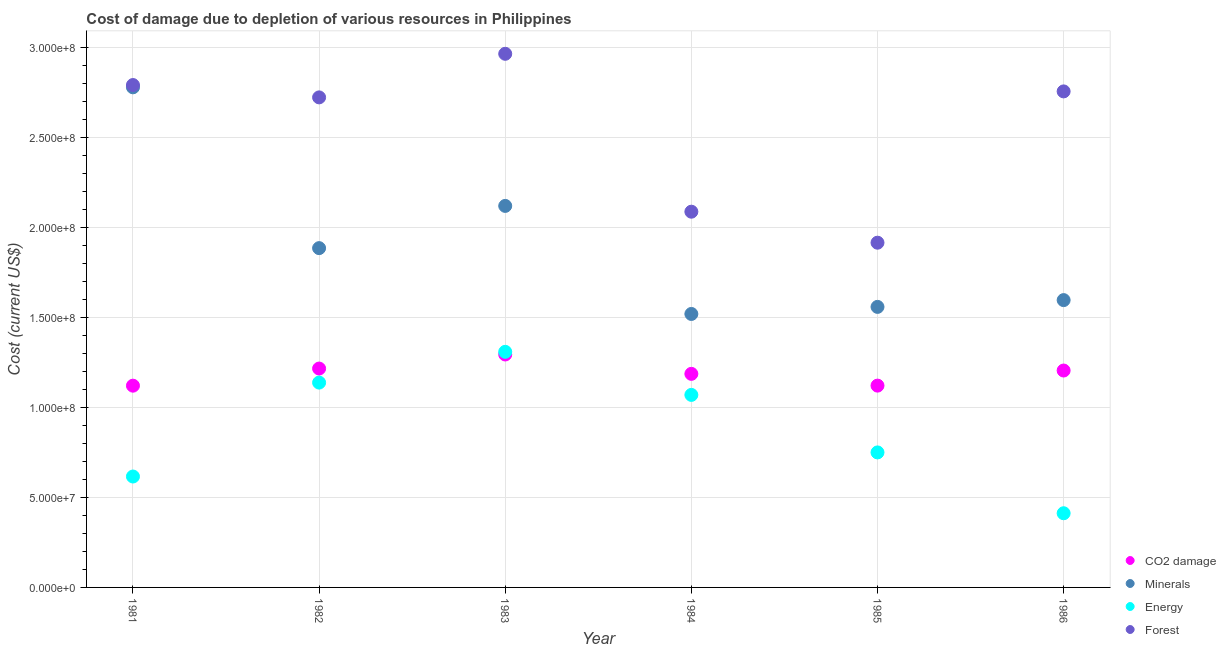How many different coloured dotlines are there?
Provide a succinct answer. 4. Is the number of dotlines equal to the number of legend labels?
Your answer should be compact. Yes. What is the cost of damage due to depletion of forests in 1981?
Provide a succinct answer. 2.79e+08. Across all years, what is the maximum cost of damage due to depletion of coal?
Ensure brevity in your answer.  1.29e+08. Across all years, what is the minimum cost of damage due to depletion of coal?
Provide a short and direct response. 1.12e+08. In which year was the cost of damage due to depletion of forests maximum?
Offer a very short reply. 1983. In which year was the cost of damage due to depletion of forests minimum?
Provide a succinct answer. 1985. What is the total cost of damage due to depletion of coal in the graph?
Provide a succinct answer. 7.14e+08. What is the difference between the cost of damage due to depletion of coal in 1983 and that in 1986?
Your response must be concise. 8.91e+06. What is the difference between the cost of damage due to depletion of minerals in 1985 and the cost of damage due to depletion of energy in 1986?
Offer a very short reply. 1.15e+08. What is the average cost of damage due to depletion of energy per year?
Ensure brevity in your answer.  8.82e+07. In the year 1986, what is the difference between the cost of damage due to depletion of energy and cost of damage due to depletion of minerals?
Keep it short and to the point. -1.18e+08. What is the ratio of the cost of damage due to depletion of coal in 1983 to that in 1986?
Your response must be concise. 1.07. Is the cost of damage due to depletion of coal in 1983 less than that in 1985?
Keep it short and to the point. No. Is the difference between the cost of damage due to depletion of forests in 1981 and 1983 greater than the difference between the cost of damage due to depletion of minerals in 1981 and 1983?
Your answer should be very brief. No. What is the difference between the highest and the second highest cost of damage due to depletion of forests?
Your answer should be compact. 1.73e+07. What is the difference between the highest and the lowest cost of damage due to depletion of forests?
Your response must be concise. 1.05e+08. Is the sum of the cost of damage due to depletion of coal in 1983 and 1984 greater than the maximum cost of damage due to depletion of forests across all years?
Your answer should be compact. No. Is it the case that in every year, the sum of the cost of damage due to depletion of coal and cost of damage due to depletion of energy is greater than the sum of cost of damage due to depletion of forests and cost of damage due to depletion of minerals?
Your answer should be compact. No. Is it the case that in every year, the sum of the cost of damage due to depletion of coal and cost of damage due to depletion of minerals is greater than the cost of damage due to depletion of energy?
Keep it short and to the point. Yes. Does the cost of damage due to depletion of coal monotonically increase over the years?
Make the answer very short. No. Is the cost of damage due to depletion of forests strictly greater than the cost of damage due to depletion of energy over the years?
Give a very brief answer. Yes. Is the cost of damage due to depletion of minerals strictly less than the cost of damage due to depletion of energy over the years?
Your answer should be compact. No. How many dotlines are there?
Ensure brevity in your answer.  4. How many years are there in the graph?
Your answer should be very brief. 6. What is the difference between two consecutive major ticks on the Y-axis?
Offer a terse response. 5.00e+07. Does the graph contain any zero values?
Give a very brief answer. No. Does the graph contain grids?
Offer a very short reply. Yes. How many legend labels are there?
Ensure brevity in your answer.  4. What is the title of the graph?
Give a very brief answer. Cost of damage due to depletion of various resources in Philippines . Does "WHO" appear as one of the legend labels in the graph?
Your response must be concise. No. What is the label or title of the Y-axis?
Ensure brevity in your answer.  Cost (current US$). What is the Cost (current US$) in CO2 damage in 1981?
Offer a terse response. 1.12e+08. What is the Cost (current US$) of Minerals in 1981?
Keep it short and to the point. 2.78e+08. What is the Cost (current US$) in Energy in 1981?
Ensure brevity in your answer.  6.16e+07. What is the Cost (current US$) of Forest in 1981?
Your response must be concise. 2.79e+08. What is the Cost (current US$) of CO2 damage in 1982?
Keep it short and to the point. 1.22e+08. What is the Cost (current US$) of Minerals in 1982?
Make the answer very short. 1.88e+08. What is the Cost (current US$) of Energy in 1982?
Ensure brevity in your answer.  1.14e+08. What is the Cost (current US$) in Forest in 1982?
Your answer should be compact. 2.72e+08. What is the Cost (current US$) of CO2 damage in 1983?
Your answer should be very brief. 1.29e+08. What is the Cost (current US$) of Minerals in 1983?
Your response must be concise. 2.12e+08. What is the Cost (current US$) in Energy in 1983?
Give a very brief answer. 1.31e+08. What is the Cost (current US$) of Forest in 1983?
Ensure brevity in your answer.  2.96e+08. What is the Cost (current US$) of CO2 damage in 1984?
Ensure brevity in your answer.  1.19e+08. What is the Cost (current US$) of Minerals in 1984?
Keep it short and to the point. 1.52e+08. What is the Cost (current US$) of Energy in 1984?
Keep it short and to the point. 1.07e+08. What is the Cost (current US$) in Forest in 1984?
Provide a succinct answer. 2.09e+08. What is the Cost (current US$) in CO2 damage in 1985?
Ensure brevity in your answer.  1.12e+08. What is the Cost (current US$) of Minerals in 1985?
Ensure brevity in your answer.  1.56e+08. What is the Cost (current US$) of Energy in 1985?
Your response must be concise. 7.50e+07. What is the Cost (current US$) in Forest in 1985?
Your response must be concise. 1.91e+08. What is the Cost (current US$) in CO2 damage in 1986?
Ensure brevity in your answer.  1.20e+08. What is the Cost (current US$) in Minerals in 1986?
Provide a short and direct response. 1.60e+08. What is the Cost (current US$) of Energy in 1986?
Your response must be concise. 4.12e+07. What is the Cost (current US$) in Forest in 1986?
Your answer should be compact. 2.75e+08. Across all years, what is the maximum Cost (current US$) in CO2 damage?
Make the answer very short. 1.29e+08. Across all years, what is the maximum Cost (current US$) of Minerals?
Keep it short and to the point. 2.78e+08. Across all years, what is the maximum Cost (current US$) in Energy?
Offer a very short reply. 1.31e+08. Across all years, what is the maximum Cost (current US$) of Forest?
Provide a succinct answer. 2.96e+08. Across all years, what is the minimum Cost (current US$) in CO2 damage?
Offer a terse response. 1.12e+08. Across all years, what is the minimum Cost (current US$) of Minerals?
Offer a very short reply. 1.52e+08. Across all years, what is the minimum Cost (current US$) in Energy?
Provide a short and direct response. 4.12e+07. Across all years, what is the minimum Cost (current US$) of Forest?
Keep it short and to the point. 1.91e+08. What is the total Cost (current US$) of CO2 damage in the graph?
Keep it short and to the point. 7.14e+08. What is the total Cost (current US$) of Minerals in the graph?
Offer a terse response. 1.15e+09. What is the total Cost (current US$) of Energy in the graph?
Ensure brevity in your answer.  5.29e+08. What is the total Cost (current US$) in Forest in the graph?
Ensure brevity in your answer.  1.52e+09. What is the difference between the Cost (current US$) of CO2 damage in 1981 and that in 1982?
Provide a short and direct response. -9.51e+06. What is the difference between the Cost (current US$) of Minerals in 1981 and that in 1982?
Your answer should be very brief. 8.93e+07. What is the difference between the Cost (current US$) in Energy in 1981 and that in 1982?
Provide a short and direct response. -5.22e+07. What is the difference between the Cost (current US$) in Forest in 1981 and that in 1982?
Keep it short and to the point. 6.86e+06. What is the difference between the Cost (current US$) in CO2 damage in 1981 and that in 1983?
Ensure brevity in your answer.  -1.73e+07. What is the difference between the Cost (current US$) in Minerals in 1981 and that in 1983?
Provide a short and direct response. 6.59e+07. What is the difference between the Cost (current US$) of Energy in 1981 and that in 1983?
Your response must be concise. -6.92e+07. What is the difference between the Cost (current US$) of Forest in 1981 and that in 1983?
Give a very brief answer. -1.73e+07. What is the difference between the Cost (current US$) in CO2 damage in 1981 and that in 1984?
Offer a terse response. -6.56e+06. What is the difference between the Cost (current US$) of Minerals in 1981 and that in 1984?
Give a very brief answer. 1.26e+08. What is the difference between the Cost (current US$) in Energy in 1981 and that in 1984?
Keep it short and to the point. -4.53e+07. What is the difference between the Cost (current US$) in Forest in 1981 and that in 1984?
Provide a succinct answer. 7.03e+07. What is the difference between the Cost (current US$) in CO2 damage in 1981 and that in 1985?
Keep it short and to the point. -2.80e+04. What is the difference between the Cost (current US$) in Minerals in 1981 and that in 1985?
Offer a very short reply. 1.22e+08. What is the difference between the Cost (current US$) in Energy in 1981 and that in 1985?
Provide a short and direct response. -1.34e+07. What is the difference between the Cost (current US$) in Forest in 1981 and that in 1985?
Provide a succinct answer. 8.76e+07. What is the difference between the Cost (current US$) of CO2 damage in 1981 and that in 1986?
Give a very brief answer. -8.41e+06. What is the difference between the Cost (current US$) of Minerals in 1981 and that in 1986?
Your response must be concise. 1.18e+08. What is the difference between the Cost (current US$) of Energy in 1981 and that in 1986?
Provide a short and direct response. 2.04e+07. What is the difference between the Cost (current US$) of Forest in 1981 and that in 1986?
Your answer should be very brief. 3.53e+06. What is the difference between the Cost (current US$) of CO2 damage in 1982 and that in 1983?
Keep it short and to the point. -7.81e+06. What is the difference between the Cost (current US$) of Minerals in 1982 and that in 1983?
Your response must be concise. -2.35e+07. What is the difference between the Cost (current US$) of Energy in 1982 and that in 1983?
Offer a terse response. -1.71e+07. What is the difference between the Cost (current US$) of Forest in 1982 and that in 1983?
Offer a terse response. -2.42e+07. What is the difference between the Cost (current US$) in CO2 damage in 1982 and that in 1984?
Offer a terse response. 2.95e+06. What is the difference between the Cost (current US$) of Minerals in 1982 and that in 1984?
Make the answer very short. 3.66e+07. What is the difference between the Cost (current US$) of Energy in 1982 and that in 1984?
Ensure brevity in your answer.  6.83e+06. What is the difference between the Cost (current US$) of Forest in 1982 and that in 1984?
Give a very brief answer. 6.35e+07. What is the difference between the Cost (current US$) in CO2 damage in 1982 and that in 1985?
Keep it short and to the point. 9.48e+06. What is the difference between the Cost (current US$) of Minerals in 1982 and that in 1985?
Keep it short and to the point. 3.26e+07. What is the difference between the Cost (current US$) of Energy in 1982 and that in 1985?
Your answer should be compact. 3.88e+07. What is the difference between the Cost (current US$) in Forest in 1982 and that in 1985?
Provide a succinct answer. 8.07e+07. What is the difference between the Cost (current US$) of CO2 damage in 1982 and that in 1986?
Provide a succinct answer. 1.10e+06. What is the difference between the Cost (current US$) in Minerals in 1982 and that in 1986?
Provide a short and direct response. 2.89e+07. What is the difference between the Cost (current US$) of Energy in 1982 and that in 1986?
Your answer should be compact. 7.26e+07. What is the difference between the Cost (current US$) in Forest in 1982 and that in 1986?
Your answer should be compact. -3.32e+06. What is the difference between the Cost (current US$) of CO2 damage in 1983 and that in 1984?
Provide a succinct answer. 1.08e+07. What is the difference between the Cost (current US$) in Minerals in 1983 and that in 1984?
Provide a succinct answer. 6.00e+07. What is the difference between the Cost (current US$) in Energy in 1983 and that in 1984?
Keep it short and to the point. 2.39e+07. What is the difference between the Cost (current US$) in Forest in 1983 and that in 1984?
Provide a succinct answer. 8.77e+07. What is the difference between the Cost (current US$) in CO2 damage in 1983 and that in 1985?
Your answer should be very brief. 1.73e+07. What is the difference between the Cost (current US$) of Minerals in 1983 and that in 1985?
Provide a succinct answer. 5.61e+07. What is the difference between the Cost (current US$) in Energy in 1983 and that in 1985?
Make the answer very short. 5.59e+07. What is the difference between the Cost (current US$) in Forest in 1983 and that in 1985?
Give a very brief answer. 1.05e+08. What is the difference between the Cost (current US$) of CO2 damage in 1983 and that in 1986?
Your answer should be compact. 8.91e+06. What is the difference between the Cost (current US$) in Minerals in 1983 and that in 1986?
Your response must be concise. 5.23e+07. What is the difference between the Cost (current US$) in Energy in 1983 and that in 1986?
Your response must be concise. 8.96e+07. What is the difference between the Cost (current US$) of Forest in 1983 and that in 1986?
Ensure brevity in your answer.  2.09e+07. What is the difference between the Cost (current US$) in CO2 damage in 1984 and that in 1985?
Your answer should be compact. 6.53e+06. What is the difference between the Cost (current US$) in Minerals in 1984 and that in 1985?
Your answer should be compact. -3.92e+06. What is the difference between the Cost (current US$) in Energy in 1984 and that in 1985?
Your answer should be very brief. 3.19e+07. What is the difference between the Cost (current US$) in Forest in 1984 and that in 1985?
Offer a very short reply. 1.72e+07. What is the difference between the Cost (current US$) of CO2 damage in 1984 and that in 1986?
Provide a short and direct response. -1.85e+06. What is the difference between the Cost (current US$) in Minerals in 1984 and that in 1986?
Offer a very short reply. -7.69e+06. What is the difference between the Cost (current US$) of Energy in 1984 and that in 1986?
Provide a succinct answer. 6.57e+07. What is the difference between the Cost (current US$) in Forest in 1984 and that in 1986?
Keep it short and to the point. -6.68e+07. What is the difference between the Cost (current US$) in CO2 damage in 1985 and that in 1986?
Provide a short and direct response. -8.38e+06. What is the difference between the Cost (current US$) of Minerals in 1985 and that in 1986?
Ensure brevity in your answer.  -3.77e+06. What is the difference between the Cost (current US$) of Energy in 1985 and that in 1986?
Provide a short and direct response. 3.38e+07. What is the difference between the Cost (current US$) of Forest in 1985 and that in 1986?
Offer a very short reply. -8.40e+07. What is the difference between the Cost (current US$) in CO2 damage in 1981 and the Cost (current US$) in Minerals in 1982?
Make the answer very short. -7.64e+07. What is the difference between the Cost (current US$) in CO2 damage in 1981 and the Cost (current US$) in Energy in 1982?
Provide a succinct answer. -1.71e+06. What is the difference between the Cost (current US$) in CO2 damage in 1981 and the Cost (current US$) in Forest in 1982?
Provide a succinct answer. -1.60e+08. What is the difference between the Cost (current US$) in Minerals in 1981 and the Cost (current US$) in Energy in 1982?
Ensure brevity in your answer.  1.64e+08. What is the difference between the Cost (current US$) of Minerals in 1981 and the Cost (current US$) of Forest in 1982?
Make the answer very short. 5.59e+06. What is the difference between the Cost (current US$) of Energy in 1981 and the Cost (current US$) of Forest in 1982?
Give a very brief answer. -2.11e+08. What is the difference between the Cost (current US$) of CO2 damage in 1981 and the Cost (current US$) of Minerals in 1983?
Provide a short and direct response. -9.98e+07. What is the difference between the Cost (current US$) of CO2 damage in 1981 and the Cost (current US$) of Energy in 1983?
Your answer should be very brief. -1.88e+07. What is the difference between the Cost (current US$) in CO2 damage in 1981 and the Cost (current US$) in Forest in 1983?
Keep it short and to the point. -1.84e+08. What is the difference between the Cost (current US$) of Minerals in 1981 and the Cost (current US$) of Energy in 1983?
Your response must be concise. 1.47e+08. What is the difference between the Cost (current US$) in Minerals in 1981 and the Cost (current US$) in Forest in 1983?
Your answer should be very brief. -1.86e+07. What is the difference between the Cost (current US$) in Energy in 1981 and the Cost (current US$) in Forest in 1983?
Make the answer very short. -2.35e+08. What is the difference between the Cost (current US$) of CO2 damage in 1981 and the Cost (current US$) of Minerals in 1984?
Ensure brevity in your answer.  -3.98e+07. What is the difference between the Cost (current US$) of CO2 damage in 1981 and the Cost (current US$) of Energy in 1984?
Keep it short and to the point. 5.12e+06. What is the difference between the Cost (current US$) in CO2 damage in 1981 and the Cost (current US$) in Forest in 1984?
Your answer should be compact. -9.66e+07. What is the difference between the Cost (current US$) in Minerals in 1981 and the Cost (current US$) in Energy in 1984?
Provide a short and direct response. 1.71e+08. What is the difference between the Cost (current US$) in Minerals in 1981 and the Cost (current US$) in Forest in 1984?
Provide a succinct answer. 6.91e+07. What is the difference between the Cost (current US$) of Energy in 1981 and the Cost (current US$) of Forest in 1984?
Your answer should be very brief. -1.47e+08. What is the difference between the Cost (current US$) in CO2 damage in 1981 and the Cost (current US$) in Minerals in 1985?
Offer a very short reply. -4.38e+07. What is the difference between the Cost (current US$) in CO2 damage in 1981 and the Cost (current US$) in Energy in 1985?
Provide a succinct answer. 3.71e+07. What is the difference between the Cost (current US$) in CO2 damage in 1981 and the Cost (current US$) in Forest in 1985?
Keep it short and to the point. -7.94e+07. What is the difference between the Cost (current US$) of Minerals in 1981 and the Cost (current US$) of Energy in 1985?
Provide a short and direct response. 2.03e+08. What is the difference between the Cost (current US$) of Minerals in 1981 and the Cost (current US$) of Forest in 1985?
Your answer should be very brief. 8.63e+07. What is the difference between the Cost (current US$) in Energy in 1981 and the Cost (current US$) in Forest in 1985?
Ensure brevity in your answer.  -1.30e+08. What is the difference between the Cost (current US$) of CO2 damage in 1981 and the Cost (current US$) of Minerals in 1986?
Your answer should be very brief. -4.75e+07. What is the difference between the Cost (current US$) in CO2 damage in 1981 and the Cost (current US$) in Energy in 1986?
Your response must be concise. 7.08e+07. What is the difference between the Cost (current US$) of CO2 damage in 1981 and the Cost (current US$) of Forest in 1986?
Offer a terse response. -1.63e+08. What is the difference between the Cost (current US$) of Minerals in 1981 and the Cost (current US$) of Energy in 1986?
Give a very brief answer. 2.37e+08. What is the difference between the Cost (current US$) of Minerals in 1981 and the Cost (current US$) of Forest in 1986?
Your response must be concise. 2.27e+06. What is the difference between the Cost (current US$) in Energy in 1981 and the Cost (current US$) in Forest in 1986?
Your answer should be compact. -2.14e+08. What is the difference between the Cost (current US$) of CO2 damage in 1982 and the Cost (current US$) of Minerals in 1983?
Give a very brief answer. -9.03e+07. What is the difference between the Cost (current US$) of CO2 damage in 1982 and the Cost (current US$) of Energy in 1983?
Provide a succinct answer. -9.29e+06. What is the difference between the Cost (current US$) in CO2 damage in 1982 and the Cost (current US$) in Forest in 1983?
Provide a succinct answer. -1.75e+08. What is the difference between the Cost (current US$) in Minerals in 1982 and the Cost (current US$) in Energy in 1983?
Provide a succinct answer. 5.76e+07. What is the difference between the Cost (current US$) of Minerals in 1982 and the Cost (current US$) of Forest in 1983?
Provide a short and direct response. -1.08e+08. What is the difference between the Cost (current US$) of Energy in 1982 and the Cost (current US$) of Forest in 1983?
Provide a short and direct response. -1.83e+08. What is the difference between the Cost (current US$) in CO2 damage in 1982 and the Cost (current US$) in Minerals in 1984?
Offer a terse response. -3.03e+07. What is the difference between the Cost (current US$) of CO2 damage in 1982 and the Cost (current US$) of Energy in 1984?
Give a very brief answer. 1.46e+07. What is the difference between the Cost (current US$) in CO2 damage in 1982 and the Cost (current US$) in Forest in 1984?
Offer a very short reply. -8.71e+07. What is the difference between the Cost (current US$) in Minerals in 1982 and the Cost (current US$) in Energy in 1984?
Your answer should be compact. 8.15e+07. What is the difference between the Cost (current US$) of Minerals in 1982 and the Cost (current US$) of Forest in 1984?
Offer a very short reply. -2.02e+07. What is the difference between the Cost (current US$) of Energy in 1982 and the Cost (current US$) of Forest in 1984?
Your answer should be very brief. -9.49e+07. What is the difference between the Cost (current US$) of CO2 damage in 1982 and the Cost (current US$) of Minerals in 1985?
Provide a succinct answer. -3.42e+07. What is the difference between the Cost (current US$) of CO2 damage in 1982 and the Cost (current US$) of Energy in 1985?
Your answer should be compact. 4.66e+07. What is the difference between the Cost (current US$) of CO2 damage in 1982 and the Cost (current US$) of Forest in 1985?
Give a very brief answer. -6.99e+07. What is the difference between the Cost (current US$) of Minerals in 1982 and the Cost (current US$) of Energy in 1985?
Your response must be concise. 1.13e+08. What is the difference between the Cost (current US$) of Minerals in 1982 and the Cost (current US$) of Forest in 1985?
Your response must be concise. -3.02e+06. What is the difference between the Cost (current US$) in Energy in 1982 and the Cost (current US$) in Forest in 1985?
Your response must be concise. -7.77e+07. What is the difference between the Cost (current US$) in CO2 damage in 1982 and the Cost (current US$) in Minerals in 1986?
Give a very brief answer. -3.80e+07. What is the difference between the Cost (current US$) of CO2 damage in 1982 and the Cost (current US$) of Energy in 1986?
Your answer should be very brief. 8.04e+07. What is the difference between the Cost (current US$) of CO2 damage in 1982 and the Cost (current US$) of Forest in 1986?
Offer a terse response. -1.54e+08. What is the difference between the Cost (current US$) of Minerals in 1982 and the Cost (current US$) of Energy in 1986?
Your answer should be very brief. 1.47e+08. What is the difference between the Cost (current US$) of Minerals in 1982 and the Cost (current US$) of Forest in 1986?
Make the answer very short. -8.70e+07. What is the difference between the Cost (current US$) of Energy in 1982 and the Cost (current US$) of Forest in 1986?
Keep it short and to the point. -1.62e+08. What is the difference between the Cost (current US$) in CO2 damage in 1983 and the Cost (current US$) in Minerals in 1984?
Provide a short and direct response. -2.25e+07. What is the difference between the Cost (current US$) in CO2 damage in 1983 and the Cost (current US$) in Energy in 1984?
Your answer should be very brief. 2.24e+07. What is the difference between the Cost (current US$) of CO2 damage in 1983 and the Cost (current US$) of Forest in 1984?
Provide a succinct answer. -7.93e+07. What is the difference between the Cost (current US$) of Minerals in 1983 and the Cost (current US$) of Energy in 1984?
Offer a very short reply. 1.05e+08. What is the difference between the Cost (current US$) in Minerals in 1983 and the Cost (current US$) in Forest in 1984?
Ensure brevity in your answer.  3.21e+06. What is the difference between the Cost (current US$) of Energy in 1983 and the Cost (current US$) of Forest in 1984?
Give a very brief answer. -7.78e+07. What is the difference between the Cost (current US$) in CO2 damage in 1983 and the Cost (current US$) in Minerals in 1985?
Offer a very short reply. -2.64e+07. What is the difference between the Cost (current US$) of CO2 damage in 1983 and the Cost (current US$) of Energy in 1985?
Ensure brevity in your answer.  5.44e+07. What is the difference between the Cost (current US$) of CO2 damage in 1983 and the Cost (current US$) of Forest in 1985?
Provide a succinct answer. -6.21e+07. What is the difference between the Cost (current US$) in Minerals in 1983 and the Cost (current US$) in Energy in 1985?
Provide a succinct answer. 1.37e+08. What is the difference between the Cost (current US$) of Minerals in 1983 and the Cost (current US$) of Forest in 1985?
Give a very brief answer. 2.04e+07. What is the difference between the Cost (current US$) of Energy in 1983 and the Cost (current US$) of Forest in 1985?
Give a very brief answer. -6.06e+07. What is the difference between the Cost (current US$) in CO2 damage in 1983 and the Cost (current US$) in Minerals in 1986?
Provide a short and direct response. -3.02e+07. What is the difference between the Cost (current US$) of CO2 damage in 1983 and the Cost (current US$) of Energy in 1986?
Provide a succinct answer. 8.82e+07. What is the difference between the Cost (current US$) of CO2 damage in 1983 and the Cost (current US$) of Forest in 1986?
Your answer should be compact. -1.46e+08. What is the difference between the Cost (current US$) in Minerals in 1983 and the Cost (current US$) in Energy in 1986?
Offer a very short reply. 1.71e+08. What is the difference between the Cost (current US$) in Minerals in 1983 and the Cost (current US$) in Forest in 1986?
Your answer should be compact. -6.36e+07. What is the difference between the Cost (current US$) in Energy in 1983 and the Cost (current US$) in Forest in 1986?
Your answer should be very brief. -1.45e+08. What is the difference between the Cost (current US$) in CO2 damage in 1984 and the Cost (current US$) in Minerals in 1985?
Your answer should be compact. -3.72e+07. What is the difference between the Cost (current US$) in CO2 damage in 1984 and the Cost (current US$) in Energy in 1985?
Make the answer very short. 4.36e+07. What is the difference between the Cost (current US$) of CO2 damage in 1984 and the Cost (current US$) of Forest in 1985?
Provide a short and direct response. -7.28e+07. What is the difference between the Cost (current US$) of Minerals in 1984 and the Cost (current US$) of Energy in 1985?
Your answer should be compact. 7.69e+07. What is the difference between the Cost (current US$) of Minerals in 1984 and the Cost (current US$) of Forest in 1985?
Your response must be concise. -3.96e+07. What is the difference between the Cost (current US$) in Energy in 1984 and the Cost (current US$) in Forest in 1985?
Offer a very short reply. -8.45e+07. What is the difference between the Cost (current US$) of CO2 damage in 1984 and the Cost (current US$) of Minerals in 1986?
Provide a short and direct response. -4.10e+07. What is the difference between the Cost (current US$) in CO2 damage in 1984 and the Cost (current US$) in Energy in 1986?
Keep it short and to the point. 7.74e+07. What is the difference between the Cost (current US$) in CO2 damage in 1984 and the Cost (current US$) in Forest in 1986?
Your answer should be compact. -1.57e+08. What is the difference between the Cost (current US$) in Minerals in 1984 and the Cost (current US$) in Energy in 1986?
Your answer should be very brief. 1.11e+08. What is the difference between the Cost (current US$) of Minerals in 1984 and the Cost (current US$) of Forest in 1986?
Provide a succinct answer. -1.24e+08. What is the difference between the Cost (current US$) of Energy in 1984 and the Cost (current US$) of Forest in 1986?
Offer a terse response. -1.69e+08. What is the difference between the Cost (current US$) of CO2 damage in 1985 and the Cost (current US$) of Minerals in 1986?
Give a very brief answer. -4.75e+07. What is the difference between the Cost (current US$) in CO2 damage in 1985 and the Cost (current US$) in Energy in 1986?
Your answer should be compact. 7.09e+07. What is the difference between the Cost (current US$) of CO2 damage in 1985 and the Cost (current US$) of Forest in 1986?
Make the answer very short. -1.63e+08. What is the difference between the Cost (current US$) of Minerals in 1985 and the Cost (current US$) of Energy in 1986?
Offer a very short reply. 1.15e+08. What is the difference between the Cost (current US$) of Minerals in 1985 and the Cost (current US$) of Forest in 1986?
Make the answer very short. -1.20e+08. What is the difference between the Cost (current US$) in Energy in 1985 and the Cost (current US$) in Forest in 1986?
Your answer should be very brief. -2.00e+08. What is the average Cost (current US$) in CO2 damage per year?
Ensure brevity in your answer.  1.19e+08. What is the average Cost (current US$) in Minerals per year?
Give a very brief answer. 1.91e+08. What is the average Cost (current US$) in Energy per year?
Ensure brevity in your answer.  8.82e+07. What is the average Cost (current US$) of Forest per year?
Your answer should be very brief. 2.54e+08. In the year 1981, what is the difference between the Cost (current US$) in CO2 damage and Cost (current US$) in Minerals?
Your answer should be compact. -1.66e+08. In the year 1981, what is the difference between the Cost (current US$) of CO2 damage and Cost (current US$) of Energy?
Your response must be concise. 5.04e+07. In the year 1981, what is the difference between the Cost (current US$) in CO2 damage and Cost (current US$) in Forest?
Ensure brevity in your answer.  -1.67e+08. In the year 1981, what is the difference between the Cost (current US$) of Minerals and Cost (current US$) of Energy?
Provide a succinct answer. 2.16e+08. In the year 1981, what is the difference between the Cost (current US$) of Minerals and Cost (current US$) of Forest?
Offer a very short reply. -1.27e+06. In the year 1981, what is the difference between the Cost (current US$) of Energy and Cost (current US$) of Forest?
Make the answer very short. -2.17e+08. In the year 1982, what is the difference between the Cost (current US$) of CO2 damage and Cost (current US$) of Minerals?
Make the answer very short. -6.69e+07. In the year 1982, what is the difference between the Cost (current US$) of CO2 damage and Cost (current US$) of Energy?
Offer a very short reply. 7.80e+06. In the year 1982, what is the difference between the Cost (current US$) in CO2 damage and Cost (current US$) in Forest?
Your answer should be compact. -1.51e+08. In the year 1982, what is the difference between the Cost (current US$) in Minerals and Cost (current US$) in Energy?
Provide a succinct answer. 7.47e+07. In the year 1982, what is the difference between the Cost (current US$) of Minerals and Cost (current US$) of Forest?
Keep it short and to the point. -8.37e+07. In the year 1982, what is the difference between the Cost (current US$) in Energy and Cost (current US$) in Forest?
Your answer should be very brief. -1.58e+08. In the year 1983, what is the difference between the Cost (current US$) in CO2 damage and Cost (current US$) in Minerals?
Offer a very short reply. -8.25e+07. In the year 1983, what is the difference between the Cost (current US$) in CO2 damage and Cost (current US$) in Energy?
Your answer should be very brief. -1.48e+06. In the year 1983, what is the difference between the Cost (current US$) in CO2 damage and Cost (current US$) in Forest?
Your answer should be very brief. -1.67e+08. In the year 1983, what is the difference between the Cost (current US$) of Minerals and Cost (current US$) of Energy?
Offer a very short reply. 8.10e+07. In the year 1983, what is the difference between the Cost (current US$) of Minerals and Cost (current US$) of Forest?
Give a very brief answer. -8.45e+07. In the year 1983, what is the difference between the Cost (current US$) of Energy and Cost (current US$) of Forest?
Provide a succinct answer. -1.66e+08. In the year 1984, what is the difference between the Cost (current US$) of CO2 damage and Cost (current US$) of Minerals?
Your answer should be compact. -3.33e+07. In the year 1984, what is the difference between the Cost (current US$) of CO2 damage and Cost (current US$) of Energy?
Give a very brief answer. 1.17e+07. In the year 1984, what is the difference between the Cost (current US$) in CO2 damage and Cost (current US$) in Forest?
Give a very brief answer. -9.01e+07. In the year 1984, what is the difference between the Cost (current US$) in Minerals and Cost (current US$) in Energy?
Your answer should be very brief. 4.50e+07. In the year 1984, what is the difference between the Cost (current US$) of Minerals and Cost (current US$) of Forest?
Ensure brevity in your answer.  -5.68e+07. In the year 1984, what is the difference between the Cost (current US$) of Energy and Cost (current US$) of Forest?
Make the answer very short. -1.02e+08. In the year 1985, what is the difference between the Cost (current US$) of CO2 damage and Cost (current US$) of Minerals?
Keep it short and to the point. -4.37e+07. In the year 1985, what is the difference between the Cost (current US$) in CO2 damage and Cost (current US$) in Energy?
Keep it short and to the point. 3.71e+07. In the year 1985, what is the difference between the Cost (current US$) of CO2 damage and Cost (current US$) of Forest?
Ensure brevity in your answer.  -7.94e+07. In the year 1985, what is the difference between the Cost (current US$) of Minerals and Cost (current US$) of Energy?
Give a very brief answer. 8.08e+07. In the year 1985, what is the difference between the Cost (current US$) of Minerals and Cost (current US$) of Forest?
Your response must be concise. -3.56e+07. In the year 1985, what is the difference between the Cost (current US$) in Energy and Cost (current US$) in Forest?
Your answer should be compact. -1.16e+08. In the year 1986, what is the difference between the Cost (current US$) of CO2 damage and Cost (current US$) of Minerals?
Offer a terse response. -3.91e+07. In the year 1986, what is the difference between the Cost (current US$) in CO2 damage and Cost (current US$) in Energy?
Offer a terse response. 7.93e+07. In the year 1986, what is the difference between the Cost (current US$) of CO2 damage and Cost (current US$) of Forest?
Keep it short and to the point. -1.55e+08. In the year 1986, what is the difference between the Cost (current US$) in Minerals and Cost (current US$) in Energy?
Keep it short and to the point. 1.18e+08. In the year 1986, what is the difference between the Cost (current US$) of Minerals and Cost (current US$) of Forest?
Offer a very short reply. -1.16e+08. In the year 1986, what is the difference between the Cost (current US$) of Energy and Cost (current US$) of Forest?
Provide a short and direct response. -2.34e+08. What is the ratio of the Cost (current US$) in CO2 damage in 1981 to that in 1982?
Your response must be concise. 0.92. What is the ratio of the Cost (current US$) in Minerals in 1981 to that in 1982?
Provide a succinct answer. 1.47. What is the ratio of the Cost (current US$) in Energy in 1981 to that in 1982?
Your answer should be compact. 0.54. What is the ratio of the Cost (current US$) of Forest in 1981 to that in 1982?
Provide a succinct answer. 1.03. What is the ratio of the Cost (current US$) in CO2 damage in 1981 to that in 1983?
Your answer should be compact. 0.87. What is the ratio of the Cost (current US$) of Minerals in 1981 to that in 1983?
Provide a succinct answer. 1.31. What is the ratio of the Cost (current US$) of Energy in 1981 to that in 1983?
Your answer should be very brief. 0.47. What is the ratio of the Cost (current US$) in Forest in 1981 to that in 1983?
Make the answer very short. 0.94. What is the ratio of the Cost (current US$) in CO2 damage in 1981 to that in 1984?
Offer a terse response. 0.94. What is the ratio of the Cost (current US$) in Minerals in 1981 to that in 1984?
Keep it short and to the point. 1.83. What is the ratio of the Cost (current US$) in Energy in 1981 to that in 1984?
Provide a short and direct response. 0.58. What is the ratio of the Cost (current US$) in Forest in 1981 to that in 1984?
Make the answer very short. 1.34. What is the ratio of the Cost (current US$) of Minerals in 1981 to that in 1985?
Offer a terse response. 1.78. What is the ratio of the Cost (current US$) in Energy in 1981 to that in 1985?
Give a very brief answer. 0.82. What is the ratio of the Cost (current US$) of Forest in 1981 to that in 1985?
Provide a succinct answer. 1.46. What is the ratio of the Cost (current US$) in CO2 damage in 1981 to that in 1986?
Offer a very short reply. 0.93. What is the ratio of the Cost (current US$) of Minerals in 1981 to that in 1986?
Give a very brief answer. 1.74. What is the ratio of the Cost (current US$) in Energy in 1981 to that in 1986?
Give a very brief answer. 1.5. What is the ratio of the Cost (current US$) of Forest in 1981 to that in 1986?
Provide a succinct answer. 1.01. What is the ratio of the Cost (current US$) of CO2 damage in 1982 to that in 1983?
Provide a short and direct response. 0.94. What is the ratio of the Cost (current US$) in Minerals in 1982 to that in 1983?
Keep it short and to the point. 0.89. What is the ratio of the Cost (current US$) of Energy in 1982 to that in 1983?
Your answer should be compact. 0.87. What is the ratio of the Cost (current US$) in Forest in 1982 to that in 1983?
Provide a short and direct response. 0.92. What is the ratio of the Cost (current US$) of CO2 damage in 1982 to that in 1984?
Offer a terse response. 1.02. What is the ratio of the Cost (current US$) of Minerals in 1982 to that in 1984?
Keep it short and to the point. 1.24. What is the ratio of the Cost (current US$) of Energy in 1982 to that in 1984?
Offer a terse response. 1.06. What is the ratio of the Cost (current US$) in Forest in 1982 to that in 1984?
Give a very brief answer. 1.3. What is the ratio of the Cost (current US$) of CO2 damage in 1982 to that in 1985?
Your answer should be compact. 1.08. What is the ratio of the Cost (current US$) in Minerals in 1982 to that in 1985?
Keep it short and to the point. 1.21. What is the ratio of the Cost (current US$) of Energy in 1982 to that in 1985?
Your answer should be very brief. 1.52. What is the ratio of the Cost (current US$) in Forest in 1982 to that in 1985?
Offer a very short reply. 1.42. What is the ratio of the Cost (current US$) in CO2 damage in 1982 to that in 1986?
Provide a short and direct response. 1.01. What is the ratio of the Cost (current US$) in Minerals in 1982 to that in 1986?
Your response must be concise. 1.18. What is the ratio of the Cost (current US$) in Energy in 1982 to that in 1986?
Your answer should be very brief. 2.76. What is the ratio of the Cost (current US$) of Forest in 1982 to that in 1986?
Offer a very short reply. 0.99. What is the ratio of the Cost (current US$) of CO2 damage in 1983 to that in 1984?
Make the answer very short. 1.09. What is the ratio of the Cost (current US$) of Minerals in 1983 to that in 1984?
Your response must be concise. 1.4. What is the ratio of the Cost (current US$) of Energy in 1983 to that in 1984?
Give a very brief answer. 1.22. What is the ratio of the Cost (current US$) of Forest in 1983 to that in 1984?
Offer a very short reply. 1.42. What is the ratio of the Cost (current US$) in CO2 damage in 1983 to that in 1985?
Offer a very short reply. 1.15. What is the ratio of the Cost (current US$) of Minerals in 1983 to that in 1985?
Your response must be concise. 1.36. What is the ratio of the Cost (current US$) in Energy in 1983 to that in 1985?
Provide a short and direct response. 1.75. What is the ratio of the Cost (current US$) in Forest in 1983 to that in 1985?
Your answer should be compact. 1.55. What is the ratio of the Cost (current US$) of CO2 damage in 1983 to that in 1986?
Ensure brevity in your answer.  1.07. What is the ratio of the Cost (current US$) of Minerals in 1983 to that in 1986?
Give a very brief answer. 1.33. What is the ratio of the Cost (current US$) in Energy in 1983 to that in 1986?
Make the answer very short. 3.18. What is the ratio of the Cost (current US$) of Forest in 1983 to that in 1986?
Your response must be concise. 1.08. What is the ratio of the Cost (current US$) in CO2 damage in 1984 to that in 1985?
Offer a very short reply. 1.06. What is the ratio of the Cost (current US$) of Minerals in 1984 to that in 1985?
Make the answer very short. 0.97. What is the ratio of the Cost (current US$) in Energy in 1984 to that in 1985?
Offer a very short reply. 1.43. What is the ratio of the Cost (current US$) of Forest in 1984 to that in 1985?
Provide a succinct answer. 1.09. What is the ratio of the Cost (current US$) in CO2 damage in 1984 to that in 1986?
Offer a terse response. 0.98. What is the ratio of the Cost (current US$) in Minerals in 1984 to that in 1986?
Offer a very short reply. 0.95. What is the ratio of the Cost (current US$) of Energy in 1984 to that in 1986?
Provide a succinct answer. 2.6. What is the ratio of the Cost (current US$) in Forest in 1984 to that in 1986?
Keep it short and to the point. 0.76. What is the ratio of the Cost (current US$) in CO2 damage in 1985 to that in 1986?
Your answer should be compact. 0.93. What is the ratio of the Cost (current US$) in Minerals in 1985 to that in 1986?
Offer a very short reply. 0.98. What is the ratio of the Cost (current US$) of Energy in 1985 to that in 1986?
Offer a very short reply. 1.82. What is the ratio of the Cost (current US$) of Forest in 1985 to that in 1986?
Offer a very short reply. 0.69. What is the difference between the highest and the second highest Cost (current US$) of CO2 damage?
Your response must be concise. 7.81e+06. What is the difference between the highest and the second highest Cost (current US$) in Minerals?
Your answer should be compact. 6.59e+07. What is the difference between the highest and the second highest Cost (current US$) of Energy?
Your response must be concise. 1.71e+07. What is the difference between the highest and the second highest Cost (current US$) in Forest?
Make the answer very short. 1.73e+07. What is the difference between the highest and the lowest Cost (current US$) of CO2 damage?
Keep it short and to the point. 1.73e+07. What is the difference between the highest and the lowest Cost (current US$) in Minerals?
Offer a terse response. 1.26e+08. What is the difference between the highest and the lowest Cost (current US$) in Energy?
Provide a succinct answer. 8.96e+07. What is the difference between the highest and the lowest Cost (current US$) in Forest?
Your response must be concise. 1.05e+08. 